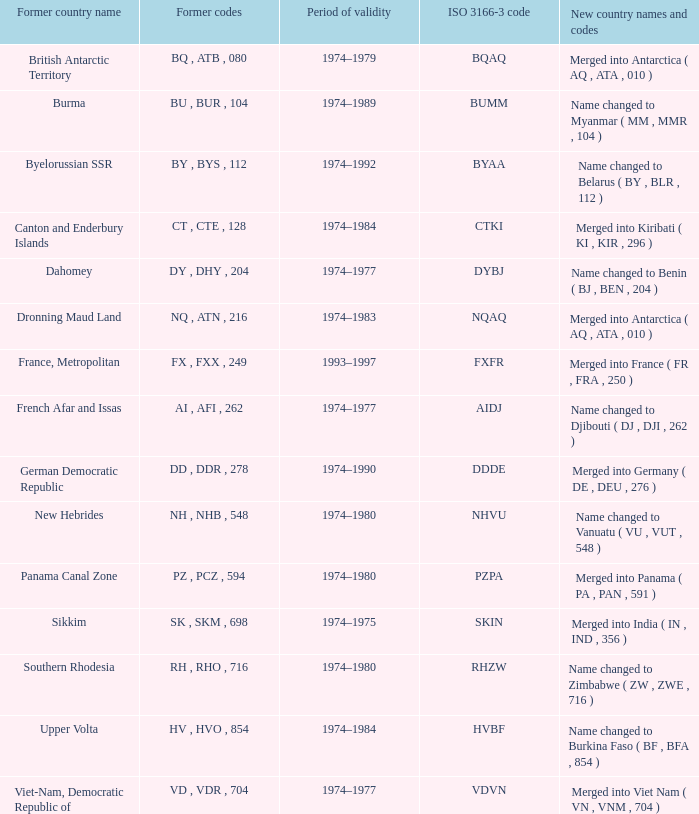Name the total number for period of validity for upper volta 1.0. 